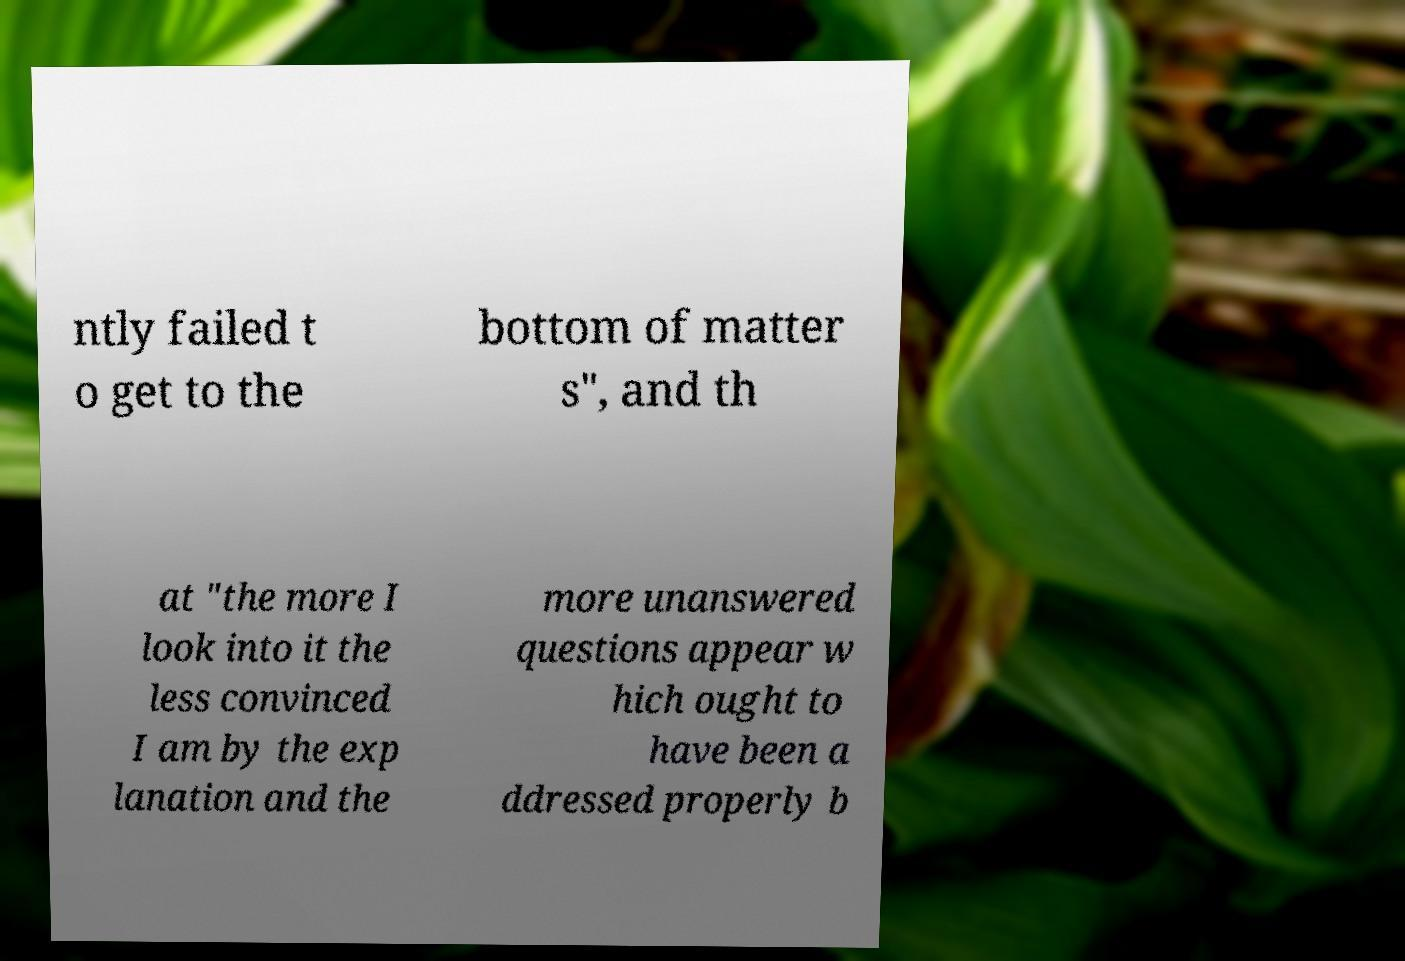Can you accurately transcribe the text from the provided image for me? ntly failed t o get to the bottom of matter s", and th at "the more I look into it the less convinced I am by the exp lanation and the more unanswered questions appear w hich ought to have been a ddressed properly b 